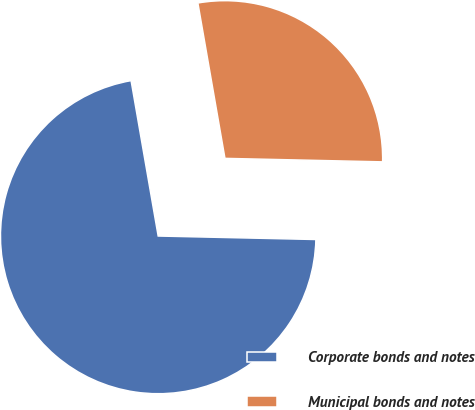Convert chart to OTSL. <chart><loc_0><loc_0><loc_500><loc_500><pie_chart><fcel>Corporate bonds and notes<fcel>Municipal bonds and notes<nl><fcel>71.9%<fcel>28.1%<nl></chart> 